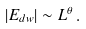Convert formula to latex. <formula><loc_0><loc_0><loc_500><loc_500>| E _ { d w } | \sim L ^ { \theta } \, .</formula> 